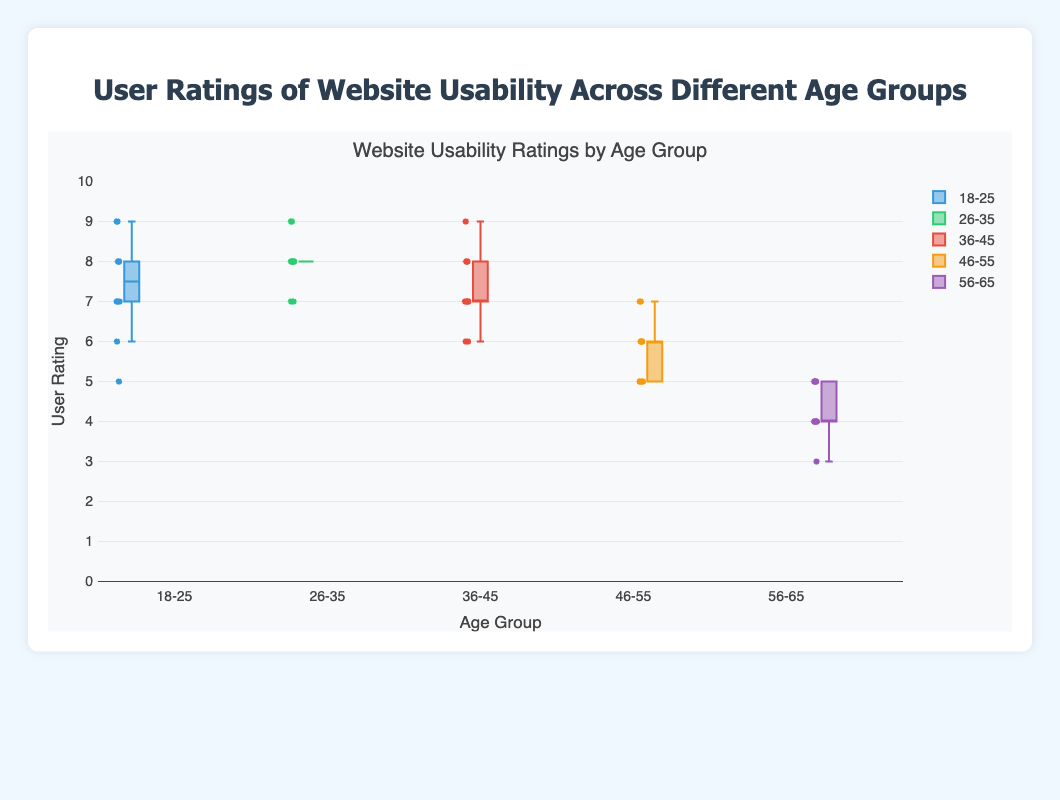Which age group has the lowest median rating? Looking at the center line in each box, which indicates the median, the 56-65 age group has the lowest median rating.
Answer: 56-65 What are the maximum and minimum user ratings in the 18-25 age group? In the 18-25 age group, the whiskers extend to the maximum rating of 9 and minimum rating of 5.
Answer: Maximum: 9, Minimum: 5 Which age group has the widest interquartile range (IQR)? The IQR is the difference between the third quartile (Q3) and the first quartile (Q1). The 56-65 age group has the widest IQR, indicating the most variability.
Answer: 56-65 How do the median ratings compare between the 26-35 and 46-55 age groups? Comparing the center lines of the boxes, the 26-35 age group has a higher median rating than the 46-55 age group.
Answer: 26-35 is higher Which age group has the highest median user rating? The highest center line on the plot is for the 26-35 age group.
Answer: 26-35 What is the interquartile range (IQR) for the 36-45 age group? For the 36-45 age group, Q3 is 8 and Q1 is 6. The IQR is Q3 - Q1.
Answer: IQR: 2 Do any age groups have outliers in the user ratings? The outliers are indicated by individual points outside the whiskers; the 18-25 age group has an outlier at the lower end (rating of 5).
Answer: Yes Which age group has the narrowest range of user ratings? The range is measured from the bottom to the top whisker. The 26-35 age group has the narrowest range of ratings from 7 to 9.
Answer: 26-35 Is the skewness of user ratings for the 46-55 age group more towards the higher or lower end? The box for the 46-55 age group is skewed to the lower end (more data points and a lower median value).
Answer: Lower end 